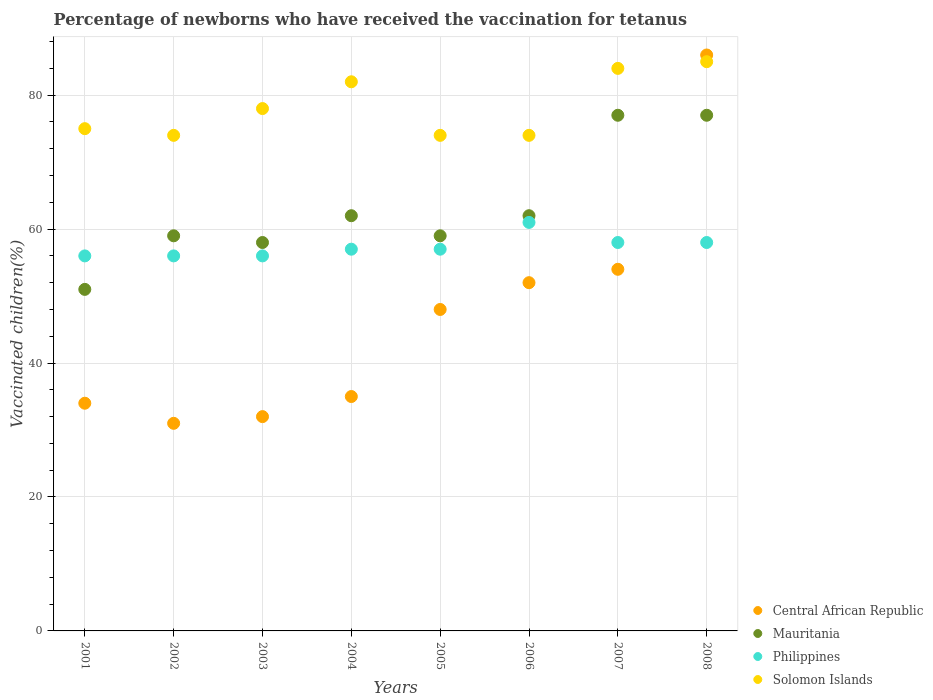How many different coloured dotlines are there?
Offer a very short reply. 4. What is the percentage of vaccinated children in Philippines in 2002?
Make the answer very short. 56. Across all years, what is the maximum percentage of vaccinated children in Central African Republic?
Give a very brief answer. 86. In which year was the percentage of vaccinated children in Philippines maximum?
Give a very brief answer. 2006. What is the total percentage of vaccinated children in Mauritania in the graph?
Provide a succinct answer. 505. What is the difference between the percentage of vaccinated children in Philippines in 2001 and that in 2006?
Your answer should be very brief. -5. What is the difference between the percentage of vaccinated children in Philippines in 2001 and the percentage of vaccinated children in Central African Republic in 2007?
Offer a terse response. 2. What is the average percentage of vaccinated children in Mauritania per year?
Make the answer very short. 63.12. In the year 2008, what is the difference between the percentage of vaccinated children in Central African Republic and percentage of vaccinated children in Mauritania?
Provide a short and direct response. 9. In how many years, is the percentage of vaccinated children in Central African Republic greater than 60 %?
Offer a very short reply. 1. What is the ratio of the percentage of vaccinated children in Solomon Islands in 2004 to that in 2008?
Provide a succinct answer. 0.96. Is the percentage of vaccinated children in Mauritania in 2001 less than that in 2007?
Keep it short and to the point. Yes. Is the difference between the percentage of vaccinated children in Central African Republic in 2002 and 2006 greater than the difference between the percentage of vaccinated children in Mauritania in 2002 and 2006?
Keep it short and to the point. No. What is the difference between the highest and the second highest percentage of vaccinated children in Philippines?
Ensure brevity in your answer.  3. What is the difference between the highest and the lowest percentage of vaccinated children in Solomon Islands?
Ensure brevity in your answer.  11. Is the sum of the percentage of vaccinated children in Central African Republic in 2003 and 2004 greater than the maximum percentage of vaccinated children in Solomon Islands across all years?
Keep it short and to the point. No. Is the percentage of vaccinated children in Philippines strictly less than the percentage of vaccinated children in Mauritania over the years?
Your answer should be very brief. No. How many years are there in the graph?
Offer a very short reply. 8. What is the difference between two consecutive major ticks on the Y-axis?
Offer a very short reply. 20. Does the graph contain any zero values?
Offer a very short reply. No. Where does the legend appear in the graph?
Your response must be concise. Bottom right. How are the legend labels stacked?
Offer a terse response. Vertical. What is the title of the graph?
Your answer should be compact. Percentage of newborns who have received the vaccination for tetanus. Does "Bermuda" appear as one of the legend labels in the graph?
Provide a succinct answer. No. What is the label or title of the Y-axis?
Ensure brevity in your answer.  Vaccinated children(%). What is the Vaccinated children(%) in Philippines in 2001?
Keep it short and to the point. 56. What is the Vaccinated children(%) in Philippines in 2002?
Give a very brief answer. 56. What is the Vaccinated children(%) of Solomon Islands in 2002?
Ensure brevity in your answer.  74. What is the Vaccinated children(%) in Central African Republic in 2003?
Make the answer very short. 32. What is the Vaccinated children(%) in Mauritania in 2003?
Your response must be concise. 58. What is the Vaccinated children(%) in Philippines in 2004?
Provide a succinct answer. 57. What is the Vaccinated children(%) in Solomon Islands in 2004?
Provide a succinct answer. 82. What is the Vaccinated children(%) in Solomon Islands in 2005?
Ensure brevity in your answer.  74. What is the Vaccinated children(%) in Central African Republic in 2006?
Keep it short and to the point. 52. What is the Vaccinated children(%) in Central African Republic in 2007?
Make the answer very short. 54. What is the Vaccinated children(%) in Solomon Islands in 2007?
Provide a succinct answer. 84. What is the Vaccinated children(%) in Central African Republic in 2008?
Your response must be concise. 86. What is the Vaccinated children(%) in Solomon Islands in 2008?
Provide a succinct answer. 85. Across all years, what is the maximum Vaccinated children(%) in Philippines?
Make the answer very short. 61. Across all years, what is the maximum Vaccinated children(%) of Solomon Islands?
Provide a short and direct response. 85. Across all years, what is the minimum Vaccinated children(%) of Central African Republic?
Keep it short and to the point. 31. Across all years, what is the minimum Vaccinated children(%) in Solomon Islands?
Your response must be concise. 74. What is the total Vaccinated children(%) of Central African Republic in the graph?
Ensure brevity in your answer.  372. What is the total Vaccinated children(%) of Mauritania in the graph?
Keep it short and to the point. 505. What is the total Vaccinated children(%) in Philippines in the graph?
Provide a succinct answer. 459. What is the total Vaccinated children(%) of Solomon Islands in the graph?
Give a very brief answer. 626. What is the difference between the Vaccinated children(%) of Solomon Islands in 2001 and that in 2002?
Your response must be concise. 1. What is the difference between the Vaccinated children(%) in Central African Republic in 2001 and that in 2004?
Make the answer very short. -1. What is the difference between the Vaccinated children(%) in Mauritania in 2001 and that in 2004?
Keep it short and to the point. -11. What is the difference between the Vaccinated children(%) of Philippines in 2001 and that in 2004?
Make the answer very short. -1. What is the difference between the Vaccinated children(%) of Solomon Islands in 2001 and that in 2004?
Your answer should be very brief. -7. What is the difference between the Vaccinated children(%) in Central African Republic in 2001 and that in 2005?
Your answer should be very brief. -14. What is the difference between the Vaccinated children(%) in Mauritania in 2001 and that in 2005?
Offer a very short reply. -8. What is the difference between the Vaccinated children(%) of Philippines in 2001 and that in 2005?
Offer a very short reply. -1. What is the difference between the Vaccinated children(%) of Solomon Islands in 2001 and that in 2005?
Provide a short and direct response. 1. What is the difference between the Vaccinated children(%) of Central African Republic in 2001 and that in 2006?
Make the answer very short. -18. What is the difference between the Vaccinated children(%) in Philippines in 2001 and that in 2006?
Give a very brief answer. -5. What is the difference between the Vaccinated children(%) in Solomon Islands in 2001 and that in 2006?
Give a very brief answer. 1. What is the difference between the Vaccinated children(%) of Central African Republic in 2001 and that in 2007?
Your response must be concise. -20. What is the difference between the Vaccinated children(%) of Mauritania in 2001 and that in 2007?
Give a very brief answer. -26. What is the difference between the Vaccinated children(%) in Philippines in 2001 and that in 2007?
Your answer should be very brief. -2. What is the difference between the Vaccinated children(%) of Solomon Islands in 2001 and that in 2007?
Your answer should be very brief. -9. What is the difference between the Vaccinated children(%) in Central African Republic in 2001 and that in 2008?
Your answer should be compact. -52. What is the difference between the Vaccinated children(%) in Mauritania in 2002 and that in 2003?
Your answer should be very brief. 1. What is the difference between the Vaccinated children(%) of Central African Republic in 2002 and that in 2004?
Give a very brief answer. -4. What is the difference between the Vaccinated children(%) of Philippines in 2002 and that in 2004?
Give a very brief answer. -1. What is the difference between the Vaccinated children(%) of Solomon Islands in 2002 and that in 2004?
Offer a very short reply. -8. What is the difference between the Vaccinated children(%) of Central African Republic in 2002 and that in 2005?
Keep it short and to the point. -17. What is the difference between the Vaccinated children(%) in Central African Republic in 2002 and that in 2006?
Your answer should be compact. -21. What is the difference between the Vaccinated children(%) in Mauritania in 2002 and that in 2007?
Offer a terse response. -18. What is the difference between the Vaccinated children(%) of Central African Republic in 2002 and that in 2008?
Your answer should be compact. -55. What is the difference between the Vaccinated children(%) in Philippines in 2002 and that in 2008?
Give a very brief answer. -2. What is the difference between the Vaccinated children(%) of Solomon Islands in 2002 and that in 2008?
Offer a terse response. -11. What is the difference between the Vaccinated children(%) in Philippines in 2003 and that in 2004?
Provide a succinct answer. -1. What is the difference between the Vaccinated children(%) of Central African Republic in 2003 and that in 2005?
Your answer should be very brief. -16. What is the difference between the Vaccinated children(%) of Solomon Islands in 2003 and that in 2005?
Provide a short and direct response. 4. What is the difference between the Vaccinated children(%) of Mauritania in 2003 and that in 2007?
Give a very brief answer. -19. What is the difference between the Vaccinated children(%) of Central African Republic in 2003 and that in 2008?
Offer a terse response. -54. What is the difference between the Vaccinated children(%) of Mauritania in 2003 and that in 2008?
Your answer should be compact. -19. What is the difference between the Vaccinated children(%) in Mauritania in 2004 and that in 2005?
Your response must be concise. 3. What is the difference between the Vaccinated children(%) of Philippines in 2004 and that in 2005?
Offer a terse response. 0. What is the difference between the Vaccinated children(%) of Solomon Islands in 2004 and that in 2005?
Offer a very short reply. 8. What is the difference between the Vaccinated children(%) in Philippines in 2004 and that in 2006?
Make the answer very short. -4. What is the difference between the Vaccinated children(%) of Central African Republic in 2004 and that in 2007?
Give a very brief answer. -19. What is the difference between the Vaccinated children(%) in Mauritania in 2004 and that in 2007?
Provide a succinct answer. -15. What is the difference between the Vaccinated children(%) of Solomon Islands in 2004 and that in 2007?
Offer a very short reply. -2. What is the difference between the Vaccinated children(%) of Central African Republic in 2004 and that in 2008?
Offer a terse response. -51. What is the difference between the Vaccinated children(%) in Philippines in 2004 and that in 2008?
Give a very brief answer. -1. What is the difference between the Vaccinated children(%) of Solomon Islands in 2004 and that in 2008?
Ensure brevity in your answer.  -3. What is the difference between the Vaccinated children(%) in Central African Republic in 2005 and that in 2006?
Give a very brief answer. -4. What is the difference between the Vaccinated children(%) in Philippines in 2005 and that in 2006?
Offer a terse response. -4. What is the difference between the Vaccinated children(%) of Mauritania in 2005 and that in 2007?
Give a very brief answer. -18. What is the difference between the Vaccinated children(%) in Solomon Islands in 2005 and that in 2007?
Your answer should be compact. -10. What is the difference between the Vaccinated children(%) of Central African Republic in 2005 and that in 2008?
Your response must be concise. -38. What is the difference between the Vaccinated children(%) of Mauritania in 2005 and that in 2008?
Your answer should be compact. -18. What is the difference between the Vaccinated children(%) in Solomon Islands in 2006 and that in 2007?
Keep it short and to the point. -10. What is the difference between the Vaccinated children(%) of Central African Republic in 2006 and that in 2008?
Provide a succinct answer. -34. What is the difference between the Vaccinated children(%) in Mauritania in 2006 and that in 2008?
Provide a short and direct response. -15. What is the difference between the Vaccinated children(%) of Philippines in 2006 and that in 2008?
Give a very brief answer. 3. What is the difference between the Vaccinated children(%) in Solomon Islands in 2006 and that in 2008?
Provide a short and direct response. -11. What is the difference between the Vaccinated children(%) of Central African Republic in 2007 and that in 2008?
Offer a very short reply. -32. What is the difference between the Vaccinated children(%) in Mauritania in 2007 and that in 2008?
Provide a succinct answer. 0. What is the difference between the Vaccinated children(%) of Philippines in 2007 and that in 2008?
Offer a terse response. 0. What is the difference between the Vaccinated children(%) of Central African Republic in 2001 and the Vaccinated children(%) of Mauritania in 2002?
Your response must be concise. -25. What is the difference between the Vaccinated children(%) of Central African Republic in 2001 and the Vaccinated children(%) of Solomon Islands in 2002?
Keep it short and to the point. -40. What is the difference between the Vaccinated children(%) in Central African Republic in 2001 and the Vaccinated children(%) in Solomon Islands in 2003?
Your answer should be very brief. -44. What is the difference between the Vaccinated children(%) in Mauritania in 2001 and the Vaccinated children(%) in Solomon Islands in 2003?
Make the answer very short. -27. What is the difference between the Vaccinated children(%) in Philippines in 2001 and the Vaccinated children(%) in Solomon Islands in 2003?
Offer a terse response. -22. What is the difference between the Vaccinated children(%) of Central African Republic in 2001 and the Vaccinated children(%) of Solomon Islands in 2004?
Ensure brevity in your answer.  -48. What is the difference between the Vaccinated children(%) in Mauritania in 2001 and the Vaccinated children(%) in Philippines in 2004?
Ensure brevity in your answer.  -6. What is the difference between the Vaccinated children(%) in Mauritania in 2001 and the Vaccinated children(%) in Solomon Islands in 2004?
Your response must be concise. -31. What is the difference between the Vaccinated children(%) in Central African Republic in 2001 and the Vaccinated children(%) in Philippines in 2005?
Provide a short and direct response. -23. What is the difference between the Vaccinated children(%) in Mauritania in 2001 and the Vaccinated children(%) in Philippines in 2005?
Make the answer very short. -6. What is the difference between the Vaccinated children(%) in Central African Republic in 2001 and the Vaccinated children(%) in Mauritania in 2006?
Provide a succinct answer. -28. What is the difference between the Vaccinated children(%) of Central African Republic in 2001 and the Vaccinated children(%) of Mauritania in 2007?
Your answer should be compact. -43. What is the difference between the Vaccinated children(%) in Central African Republic in 2001 and the Vaccinated children(%) in Philippines in 2007?
Offer a terse response. -24. What is the difference between the Vaccinated children(%) of Central African Republic in 2001 and the Vaccinated children(%) of Solomon Islands in 2007?
Give a very brief answer. -50. What is the difference between the Vaccinated children(%) of Mauritania in 2001 and the Vaccinated children(%) of Solomon Islands in 2007?
Provide a succinct answer. -33. What is the difference between the Vaccinated children(%) of Central African Republic in 2001 and the Vaccinated children(%) of Mauritania in 2008?
Provide a succinct answer. -43. What is the difference between the Vaccinated children(%) in Central African Republic in 2001 and the Vaccinated children(%) in Philippines in 2008?
Provide a short and direct response. -24. What is the difference between the Vaccinated children(%) in Central African Republic in 2001 and the Vaccinated children(%) in Solomon Islands in 2008?
Provide a short and direct response. -51. What is the difference between the Vaccinated children(%) in Mauritania in 2001 and the Vaccinated children(%) in Philippines in 2008?
Provide a short and direct response. -7. What is the difference between the Vaccinated children(%) of Mauritania in 2001 and the Vaccinated children(%) of Solomon Islands in 2008?
Keep it short and to the point. -34. What is the difference between the Vaccinated children(%) of Central African Republic in 2002 and the Vaccinated children(%) of Solomon Islands in 2003?
Your answer should be compact. -47. What is the difference between the Vaccinated children(%) in Mauritania in 2002 and the Vaccinated children(%) in Solomon Islands in 2003?
Your answer should be compact. -19. What is the difference between the Vaccinated children(%) of Philippines in 2002 and the Vaccinated children(%) of Solomon Islands in 2003?
Provide a short and direct response. -22. What is the difference between the Vaccinated children(%) in Central African Republic in 2002 and the Vaccinated children(%) in Mauritania in 2004?
Give a very brief answer. -31. What is the difference between the Vaccinated children(%) in Central African Republic in 2002 and the Vaccinated children(%) in Solomon Islands in 2004?
Provide a succinct answer. -51. What is the difference between the Vaccinated children(%) of Philippines in 2002 and the Vaccinated children(%) of Solomon Islands in 2004?
Keep it short and to the point. -26. What is the difference between the Vaccinated children(%) of Central African Republic in 2002 and the Vaccinated children(%) of Mauritania in 2005?
Give a very brief answer. -28. What is the difference between the Vaccinated children(%) of Central African Republic in 2002 and the Vaccinated children(%) of Philippines in 2005?
Make the answer very short. -26. What is the difference between the Vaccinated children(%) of Central African Republic in 2002 and the Vaccinated children(%) of Solomon Islands in 2005?
Make the answer very short. -43. What is the difference between the Vaccinated children(%) in Philippines in 2002 and the Vaccinated children(%) in Solomon Islands in 2005?
Your answer should be very brief. -18. What is the difference between the Vaccinated children(%) in Central African Republic in 2002 and the Vaccinated children(%) in Mauritania in 2006?
Your answer should be very brief. -31. What is the difference between the Vaccinated children(%) of Central African Republic in 2002 and the Vaccinated children(%) of Solomon Islands in 2006?
Provide a short and direct response. -43. What is the difference between the Vaccinated children(%) of Mauritania in 2002 and the Vaccinated children(%) of Philippines in 2006?
Make the answer very short. -2. What is the difference between the Vaccinated children(%) of Mauritania in 2002 and the Vaccinated children(%) of Solomon Islands in 2006?
Provide a succinct answer. -15. What is the difference between the Vaccinated children(%) in Philippines in 2002 and the Vaccinated children(%) in Solomon Islands in 2006?
Your answer should be compact. -18. What is the difference between the Vaccinated children(%) in Central African Republic in 2002 and the Vaccinated children(%) in Mauritania in 2007?
Keep it short and to the point. -46. What is the difference between the Vaccinated children(%) of Central African Republic in 2002 and the Vaccinated children(%) of Solomon Islands in 2007?
Offer a terse response. -53. What is the difference between the Vaccinated children(%) in Mauritania in 2002 and the Vaccinated children(%) in Philippines in 2007?
Ensure brevity in your answer.  1. What is the difference between the Vaccinated children(%) in Central African Republic in 2002 and the Vaccinated children(%) in Mauritania in 2008?
Ensure brevity in your answer.  -46. What is the difference between the Vaccinated children(%) in Central African Republic in 2002 and the Vaccinated children(%) in Solomon Islands in 2008?
Your answer should be very brief. -54. What is the difference between the Vaccinated children(%) of Central African Republic in 2003 and the Vaccinated children(%) of Philippines in 2004?
Your answer should be very brief. -25. What is the difference between the Vaccinated children(%) in Philippines in 2003 and the Vaccinated children(%) in Solomon Islands in 2004?
Offer a very short reply. -26. What is the difference between the Vaccinated children(%) in Central African Republic in 2003 and the Vaccinated children(%) in Philippines in 2005?
Offer a terse response. -25. What is the difference between the Vaccinated children(%) in Central African Republic in 2003 and the Vaccinated children(%) in Solomon Islands in 2005?
Offer a terse response. -42. What is the difference between the Vaccinated children(%) of Central African Republic in 2003 and the Vaccinated children(%) of Mauritania in 2006?
Your answer should be compact. -30. What is the difference between the Vaccinated children(%) of Central African Republic in 2003 and the Vaccinated children(%) of Philippines in 2006?
Your answer should be very brief. -29. What is the difference between the Vaccinated children(%) of Central African Republic in 2003 and the Vaccinated children(%) of Solomon Islands in 2006?
Ensure brevity in your answer.  -42. What is the difference between the Vaccinated children(%) of Mauritania in 2003 and the Vaccinated children(%) of Philippines in 2006?
Offer a very short reply. -3. What is the difference between the Vaccinated children(%) in Central African Republic in 2003 and the Vaccinated children(%) in Mauritania in 2007?
Provide a succinct answer. -45. What is the difference between the Vaccinated children(%) of Central African Republic in 2003 and the Vaccinated children(%) of Philippines in 2007?
Your response must be concise. -26. What is the difference between the Vaccinated children(%) of Central African Republic in 2003 and the Vaccinated children(%) of Solomon Islands in 2007?
Your answer should be compact. -52. What is the difference between the Vaccinated children(%) in Mauritania in 2003 and the Vaccinated children(%) in Philippines in 2007?
Your response must be concise. 0. What is the difference between the Vaccinated children(%) in Central African Republic in 2003 and the Vaccinated children(%) in Mauritania in 2008?
Offer a terse response. -45. What is the difference between the Vaccinated children(%) of Central African Republic in 2003 and the Vaccinated children(%) of Solomon Islands in 2008?
Your response must be concise. -53. What is the difference between the Vaccinated children(%) of Mauritania in 2003 and the Vaccinated children(%) of Philippines in 2008?
Provide a succinct answer. 0. What is the difference between the Vaccinated children(%) in Mauritania in 2003 and the Vaccinated children(%) in Solomon Islands in 2008?
Make the answer very short. -27. What is the difference between the Vaccinated children(%) in Philippines in 2003 and the Vaccinated children(%) in Solomon Islands in 2008?
Provide a short and direct response. -29. What is the difference between the Vaccinated children(%) of Central African Republic in 2004 and the Vaccinated children(%) of Philippines in 2005?
Your answer should be compact. -22. What is the difference between the Vaccinated children(%) of Central African Republic in 2004 and the Vaccinated children(%) of Solomon Islands in 2005?
Your answer should be compact. -39. What is the difference between the Vaccinated children(%) in Mauritania in 2004 and the Vaccinated children(%) in Solomon Islands in 2005?
Provide a succinct answer. -12. What is the difference between the Vaccinated children(%) in Central African Republic in 2004 and the Vaccinated children(%) in Philippines in 2006?
Your answer should be compact. -26. What is the difference between the Vaccinated children(%) of Central African Republic in 2004 and the Vaccinated children(%) of Solomon Islands in 2006?
Offer a terse response. -39. What is the difference between the Vaccinated children(%) in Mauritania in 2004 and the Vaccinated children(%) in Solomon Islands in 2006?
Provide a short and direct response. -12. What is the difference between the Vaccinated children(%) in Central African Republic in 2004 and the Vaccinated children(%) in Mauritania in 2007?
Make the answer very short. -42. What is the difference between the Vaccinated children(%) of Central African Republic in 2004 and the Vaccinated children(%) of Solomon Islands in 2007?
Ensure brevity in your answer.  -49. What is the difference between the Vaccinated children(%) in Mauritania in 2004 and the Vaccinated children(%) in Philippines in 2007?
Ensure brevity in your answer.  4. What is the difference between the Vaccinated children(%) in Mauritania in 2004 and the Vaccinated children(%) in Solomon Islands in 2007?
Make the answer very short. -22. What is the difference between the Vaccinated children(%) in Philippines in 2004 and the Vaccinated children(%) in Solomon Islands in 2007?
Your response must be concise. -27. What is the difference between the Vaccinated children(%) of Central African Republic in 2004 and the Vaccinated children(%) of Mauritania in 2008?
Offer a very short reply. -42. What is the difference between the Vaccinated children(%) of Central African Republic in 2004 and the Vaccinated children(%) of Solomon Islands in 2008?
Your answer should be very brief. -50. What is the difference between the Vaccinated children(%) of Philippines in 2004 and the Vaccinated children(%) of Solomon Islands in 2008?
Keep it short and to the point. -28. What is the difference between the Vaccinated children(%) of Central African Republic in 2005 and the Vaccinated children(%) of Mauritania in 2006?
Make the answer very short. -14. What is the difference between the Vaccinated children(%) of Central African Republic in 2005 and the Vaccinated children(%) of Philippines in 2006?
Give a very brief answer. -13. What is the difference between the Vaccinated children(%) in Central African Republic in 2005 and the Vaccinated children(%) in Solomon Islands in 2006?
Your response must be concise. -26. What is the difference between the Vaccinated children(%) of Mauritania in 2005 and the Vaccinated children(%) of Philippines in 2006?
Make the answer very short. -2. What is the difference between the Vaccinated children(%) in Mauritania in 2005 and the Vaccinated children(%) in Solomon Islands in 2006?
Offer a very short reply. -15. What is the difference between the Vaccinated children(%) in Central African Republic in 2005 and the Vaccinated children(%) in Mauritania in 2007?
Give a very brief answer. -29. What is the difference between the Vaccinated children(%) in Central African Republic in 2005 and the Vaccinated children(%) in Solomon Islands in 2007?
Give a very brief answer. -36. What is the difference between the Vaccinated children(%) in Mauritania in 2005 and the Vaccinated children(%) in Philippines in 2007?
Provide a succinct answer. 1. What is the difference between the Vaccinated children(%) in Mauritania in 2005 and the Vaccinated children(%) in Solomon Islands in 2007?
Your answer should be very brief. -25. What is the difference between the Vaccinated children(%) in Central African Republic in 2005 and the Vaccinated children(%) in Mauritania in 2008?
Your answer should be very brief. -29. What is the difference between the Vaccinated children(%) in Central African Republic in 2005 and the Vaccinated children(%) in Philippines in 2008?
Your answer should be very brief. -10. What is the difference between the Vaccinated children(%) of Central African Republic in 2005 and the Vaccinated children(%) of Solomon Islands in 2008?
Provide a succinct answer. -37. What is the difference between the Vaccinated children(%) in Central African Republic in 2006 and the Vaccinated children(%) in Mauritania in 2007?
Offer a very short reply. -25. What is the difference between the Vaccinated children(%) in Central African Republic in 2006 and the Vaccinated children(%) in Philippines in 2007?
Provide a short and direct response. -6. What is the difference between the Vaccinated children(%) of Central African Republic in 2006 and the Vaccinated children(%) of Solomon Islands in 2007?
Make the answer very short. -32. What is the difference between the Vaccinated children(%) of Philippines in 2006 and the Vaccinated children(%) of Solomon Islands in 2007?
Ensure brevity in your answer.  -23. What is the difference between the Vaccinated children(%) in Central African Republic in 2006 and the Vaccinated children(%) in Solomon Islands in 2008?
Keep it short and to the point. -33. What is the difference between the Vaccinated children(%) in Central African Republic in 2007 and the Vaccinated children(%) in Solomon Islands in 2008?
Make the answer very short. -31. What is the difference between the Vaccinated children(%) in Mauritania in 2007 and the Vaccinated children(%) in Philippines in 2008?
Give a very brief answer. 19. What is the average Vaccinated children(%) of Central African Republic per year?
Offer a very short reply. 46.5. What is the average Vaccinated children(%) in Mauritania per year?
Provide a short and direct response. 63.12. What is the average Vaccinated children(%) of Philippines per year?
Your answer should be compact. 57.38. What is the average Vaccinated children(%) of Solomon Islands per year?
Your answer should be compact. 78.25. In the year 2001, what is the difference between the Vaccinated children(%) in Central African Republic and Vaccinated children(%) in Mauritania?
Offer a very short reply. -17. In the year 2001, what is the difference between the Vaccinated children(%) in Central African Republic and Vaccinated children(%) in Philippines?
Provide a short and direct response. -22. In the year 2001, what is the difference between the Vaccinated children(%) of Central African Republic and Vaccinated children(%) of Solomon Islands?
Your answer should be compact. -41. In the year 2001, what is the difference between the Vaccinated children(%) of Mauritania and Vaccinated children(%) of Solomon Islands?
Give a very brief answer. -24. In the year 2002, what is the difference between the Vaccinated children(%) of Central African Republic and Vaccinated children(%) of Solomon Islands?
Offer a very short reply. -43. In the year 2002, what is the difference between the Vaccinated children(%) of Mauritania and Vaccinated children(%) of Solomon Islands?
Your response must be concise. -15. In the year 2002, what is the difference between the Vaccinated children(%) of Philippines and Vaccinated children(%) of Solomon Islands?
Make the answer very short. -18. In the year 2003, what is the difference between the Vaccinated children(%) in Central African Republic and Vaccinated children(%) in Mauritania?
Ensure brevity in your answer.  -26. In the year 2003, what is the difference between the Vaccinated children(%) in Central African Republic and Vaccinated children(%) in Solomon Islands?
Provide a succinct answer. -46. In the year 2003, what is the difference between the Vaccinated children(%) of Philippines and Vaccinated children(%) of Solomon Islands?
Offer a very short reply. -22. In the year 2004, what is the difference between the Vaccinated children(%) in Central African Republic and Vaccinated children(%) in Solomon Islands?
Your answer should be very brief. -47. In the year 2004, what is the difference between the Vaccinated children(%) in Mauritania and Vaccinated children(%) in Philippines?
Your answer should be compact. 5. In the year 2005, what is the difference between the Vaccinated children(%) of Central African Republic and Vaccinated children(%) of Solomon Islands?
Ensure brevity in your answer.  -26. In the year 2006, what is the difference between the Vaccinated children(%) in Central African Republic and Vaccinated children(%) in Philippines?
Offer a terse response. -9. In the year 2006, what is the difference between the Vaccinated children(%) of Mauritania and Vaccinated children(%) of Solomon Islands?
Ensure brevity in your answer.  -12. In the year 2006, what is the difference between the Vaccinated children(%) in Philippines and Vaccinated children(%) in Solomon Islands?
Give a very brief answer. -13. In the year 2007, what is the difference between the Vaccinated children(%) in Central African Republic and Vaccinated children(%) in Mauritania?
Provide a succinct answer. -23. In the year 2007, what is the difference between the Vaccinated children(%) in Mauritania and Vaccinated children(%) in Philippines?
Your answer should be compact. 19. In the year 2007, what is the difference between the Vaccinated children(%) in Philippines and Vaccinated children(%) in Solomon Islands?
Give a very brief answer. -26. In the year 2008, what is the difference between the Vaccinated children(%) of Central African Republic and Vaccinated children(%) of Mauritania?
Your answer should be very brief. 9. In the year 2008, what is the difference between the Vaccinated children(%) of Central African Republic and Vaccinated children(%) of Solomon Islands?
Offer a terse response. 1. In the year 2008, what is the difference between the Vaccinated children(%) of Mauritania and Vaccinated children(%) of Philippines?
Offer a terse response. 19. In the year 2008, what is the difference between the Vaccinated children(%) of Mauritania and Vaccinated children(%) of Solomon Islands?
Your answer should be compact. -8. In the year 2008, what is the difference between the Vaccinated children(%) of Philippines and Vaccinated children(%) of Solomon Islands?
Make the answer very short. -27. What is the ratio of the Vaccinated children(%) in Central African Republic in 2001 to that in 2002?
Offer a terse response. 1.1. What is the ratio of the Vaccinated children(%) in Mauritania in 2001 to that in 2002?
Provide a succinct answer. 0.86. What is the ratio of the Vaccinated children(%) of Philippines in 2001 to that in 2002?
Make the answer very short. 1. What is the ratio of the Vaccinated children(%) of Solomon Islands in 2001 to that in 2002?
Your response must be concise. 1.01. What is the ratio of the Vaccinated children(%) of Mauritania in 2001 to that in 2003?
Your response must be concise. 0.88. What is the ratio of the Vaccinated children(%) of Solomon Islands in 2001 to that in 2003?
Make the answer very short. 0.96. What is the ratio of the Vaccinated children(%) of Central African Republic in 2001 to that in 2004?
Offer a terse response. 0.97. What is the ratio of the Vaccinated children(%) of Mauritania in 2001 to that in 2004?
Provide a short and direct response. 0.82. What is the ratio of the Vaccinated children(%) of Philippines in 2001 to that in 2004?
Keep it short and to the point. 0.98. What is the ratio of the Vaccinated children(%) in Solomon Islands in 2001 to that in 2004?
Offer a very short reply. 0.91. What is the ratio of the Vaccinated children(%) of Central African Republic in 2001 to that in 2005?
Keep it short and to the point. 0.71. What is the ratio of the Vaccinated children(%) in Mauritania in 2001 to that in 2005?
Provide a short and direct response. 0.86. What is the ratio of the Vaccinated children(%) of Philippines in 2001 to that in 2005?
Your answer should be very brief. 0.98. What is the ratio of the Vaccinated children(%) in Solomon Islands in 2001 to that in 2005?
Ensure brevity in your answer.  1.01. What is the ratio of the Vaccinated children(%) of Central African Republic in 2001 to that in 2006?
Your answer should be very brief. 0.65. What is the ratio of the Vaccinated children(%) in Mauritania in 2001 to that in 2006?
Provide a short and direct response. 0.82. What is the ratio of the Vaccinated children(%) of Philippines in 2001 to that in 2006?
Your answer should be very brief. 0.92. What is the ratio of the Vaccinated children(%) in Solomon Islands in 2001 to that in 2006?
Provide a succinct answer. 1.01. What is the ratio of the Vaccinated children(%) in Central African Republic in 2001 to that in 2007?
Your answer should be very brief. 0.63. What is the ratio of the Vaccinated children(%) in Mauritania in 2001 to that in 2007?
Make the answer very short. 0.66. What is the ratio of the Vaccinated children(%) of Philippines in 2001 to that in 2007?
Give a very brief answer. 0.97. What is the ratio of the Vaccinated children(%) in Solomon Islands in 2001 to that in 2007?
Ensure brevity in your answer.  0.89. What is the ratio of the Vaccinated children(%) of Central African Republic in 2001 to that in 2008?
Your answer should be compact. 0.4. What is the ratio of the Vaccinated children(%) in Mauritania in 2001 to that in 2008?
Offer a very short reply. 0.66. What is the ratio of the Vaccinated children(%) of Philippines in 2001 to that in 2008?
Keep it short and to the point. 0.97. What is the ratio of the Vaccinated children(%) in Solomon Islands in 2001 to that in 2008?
Give a very brief answer. 0.88. What is the ratio of the Vaccinated children(%) of Central African Republic in 2002 to that in 2003?
Keep it short and to the point. 0.97. What is the ratio of the Vaccinated children(%) of Mauritania in 2002 to that in 2003?
Keep it short and to the point. 1.02. What is the ratio of the Vaccinated children(%) of Philippines in 2002 to that in 2003?
Ensure brevity in your answer.  1. What is the ratio of the Vaccinated children(%) of Solomon Islands in 2002 to that in 2003?
Your answer should be very brief. 0.95. What is the ratio of the Vaccinated children(%) of Central African Republic in 2002 to that in 2004?
Offer a terse response. 0.89. What is the ratio of the Vaccinated children(%) of Mauritania in 2002 to that in 2004?
Ensure brevity in your answer.  0.95. What is the ratio of the Vaccinated children(%) of Philippines in 2002 to that in 2004?
Your response must be concise. 0.98. What is the ratio of the Vaccinated children(%) in Solomon Islands in 2002 to that in 2004?
Your response must be concise. 0.9. What is the ratio of the Vaccinated children(%) in Central African Republic in 2002 to that in 2005?
Give a very brief answer. 0.65. What is the ratio of the Vaccinated children(%) of Philippines in 2002 to that in 2005?
Offer a terse response. 0.98. What is the ratio of the Vaccinated children(%) of Solomon Islands in 2002 to that in 2005?
Your response must be concise. 1. What is the ratio of the Vaccinated children(%) of Central African Republic in 2002 to that in 2006?
Provide a short and direct response. 0.6. What is the ratio of the Vaccinated children(%) of Mauritania in 2002 to that in 2006?
Provide a succinct answer. 0.95. What is the ratio of the Vaccinated children(%) of Philippines in 2002 to that in 2006?
Your answer should be compact. 0.92. What is the ratio of the Vaccinated children(%) of Central African Republic in 2002 to that in 2007?
Offer a terse response. 0.57. What is the ratio of the Vaccinated children(%) of Mauritania in 2002 to that in 2007?
Your response must be concise. 0.77. What is the ratio of the Vaccinated children(%) of Philippines in 2002 to that in 2007?
Offer a very short reply. 0.97. What is the ratio of the Vaccinated children(%) of Solomon Islands in 2002 to that in 2007?
Ensure brevity in your answer.  0.88. What is the ratio of the Vaccinated children(%) of Central African Republic in 2002 to that in 2008?
Give a very brief answer. 0.36. What is the ratio of the Vaccinated children(%) of Mauritania in 2002 to that in 2008?
Ensure brevity in your answer.  0.77. What is the ratio of the Vaccinated children(%) of Philippines in 2002 to that in 2008?
Ensure brevity in your answer.  0.97. What is the ratio of the Vaccinated children(%) in Solomon Islands in 2002 to that in 2008?
Provide a short and direct response. 0.87. What is the ratio of the Vaccinated children(%) in Central African Republic in 2003 to that in 2004?
Your answer should be compact. 0.91. What is the ratio of the Vaccinated children(%) in Mauritania in 2003 to that in 2004?
Your response must be concise. 0.94. What is the ratio of the Vaccinated children(%) in Philippines in 2003 to that in 2004?
Make the answer very short. 0.98. What is the ratio of the Vaccinated children(%) in Solomon Islands in 2003 to that in 2004?
Provide a succinct answer. 0.95. What is the ratio of the Vaccinated children(%) of Central African Republic in 2003 to that in 2005?
Your response must be concise. 0.67. What is the ratio of the Vaccinated children(%) in Mauritania in 2003 to that in 2005?
Provide a succinct answer. 0.98. What is the ratio of the Vaccinated children(%) of Philippines in 2003 to that in 2005?
Your response must be concise. 0.98. What is the ratio of the Vaccinated children(%) of Solomon Islands in 2003 to that in 2005?
Your answer should be very brief. 1.05. What is the ratio of the Vaccinated children(%) in Central African Republic in 2003 to that in 2006?
Give a very brief answer. 0.62. What is the ratio of the Vaccinated children(%) in Mauritania in 2003 to that in 2006?
Ensure brevity in your answer.  0.94. What is the ratio of the Vaccinated children(%) of Philippines in 2003 to that in 2006?
Keep it short and to the point. 0.92. What is the ratio of the Vaccinated children(%) of Solomon Islands in 2003 to that in 2006?
Offer a very short reply. 1.05. What is the ratio of the Vaccinated children(%) of Central African Republic in 2003 to that in 2007?
Provide a short and direct response. 0.59. What is the ratio of the Vaccinated children(%) in Mauritania in 2003 to that in 2007?
Provide a succinct answer. 0.75. What is the ratio of the Vaccinated children(%) in Philippines in 2003 to that in 2007?
Give a very brief answer. 0.97. What is the ratio of the Vaccinated children(%) of Solomon Islands in 2003 to that in 2007?
Ensure brevity in your answer.  0.93. What is the ratio of the Vaccinated children(%) in Central African Republic in 2003 to that in 2008?
Your answer should be compact. 0.37. What is the ratio of the Vaccinated children(%) of Mauritania in 2003 to that in 2008?
Your response must be concise. 0.75. What is the ratio of the Vaccinated children(%) of Philippines in 2003 to that in 2008?
Keep it short and to the point. 0.97. What is the ratio of the Vaccinated children(%) in Solomon Islands in 2003 to that in 2008?
Your answer should be very brief. 0.92. What is the ratio of the Vaccinated children(%) of Central African Republic in 2004 to that in 2005?
Your response must be concise. 0.73. What is the ratio of the Vaccinated children(%) of Mauritania in 2004 to that in 2005?
Offer a terse response. 1.05. What is the ratio of the Vaccinated children(%) in Solomon Islands in 2004 to that in 2005?
Your answer should be very brief. 1.11. What is the ratio of the Vaccinated children(%) of Central African Republic in 2004 to that in 2006?
Keep it short and to the point. 0.67. What is the ratio of the Vaccinated children(%) in Philippines in 2004 to that in 2006?
Give a very brief answer. 0.93. What is the ratio of the Vaccinated children(%) of Solomon Islands in 2004 to that in 2006?
Keep it short and to the point. 1.11. What is the ratio of the Vaccinated children(%) in Central African Republic in 2004 to that in 2007?
Your answer should be compact. 0.65. What is the ratio of the Vaccinated children(%) in Mauritania in 2004 to that in 2007?
Provide a succinct answer. 0.81. What is the ratio of the Vaccinated children(%) in Philippines in 2004 to that in 2007?
Make the answer very short. 0.98. What is the ratio of the Vaccinated children(%) of Solomon Islands in 2004 to that in 2007?
Your response must be concise. 0.98. What is the ratio of the Vaccinated children(%) of Central African Republic in 2004 to that in 2008?
Ensure brevity in your answer.  0.41. What is the ratio of the Vaccinated children(%) in Mauritania in 2004 to that in 2008?
Provide a succinct answer. 0.81. What is the ratio of the Vaccinated children(%) of Philippines in 2004 to that in 2008?
Provide a short and direct response. 0.98. What is the ratio of the Vaccinated children(%) of Solomon Islands in 2004 to that in 2008?
Ensure brevity in your answer.  0.96. What is the ratio of the Vaccinated children(%) of Central African Republic in 2005 to that in 2006?
Offer a very short reply. 0.92. What is the ratio of the Vaccinated children(%) in Mauritania in 2005 to that in 2006?
Give a very brief answer. 0.95. What is the ratio of the Vaccinated children(%) in Philippines in 2005 to that in 2006?
Offer a very short reply. 0.93. What is the ratio of the Vaccinated children(%) of Solomon Islands in 2005 to that in 2006?
Give a very brief answer. 1. What is the ratio of the Vaccinated children(%) in Central African Republic in 2005 to that in 2007?
Offer a terse response. 0.89. What is the ratio of the Vaccinated children(%) of Mauritania in 2005 to that in 2007?
Give a very brief answer. 0.77. What is the ratio of the Vaccinated children(%) in Philippines in 2005 to that in 2007?
Your answer should be compact. 0.98. What is the ratio of the Vaccinated children(%) of Solomon Islands in 2005 to that in 2007?
Ensure brevity in your answer.  0.88. What is the ratio of the Vaccinated children(%) of Central African Republic in 2005 to that in 2008?
Provide a succinct answer. 0.56. What is the ratio of the Vaccinated children(%) in Mauritania in 2005 to that in 2008?
Keep it short and to the point. 0.77. What is the ratio of the Vaccinated children(%) in Philippines in 2005 to that in 2008?
Offer a very short reply. 0.98. What is the ratio of the Vaccinated children(%) of Solomon Islands in 2005 to that in 2008?
Give a very brief answer. 0.87. What is the ratio of the Vaccinated children(%) in Mauritania in 2006 to that in 2007?
Offer a terse response. 0.81. What is the ratio of the Vaccinated children(%) of Philippines in 2006 to that in 2007?
Make the answer very short. 1.05. What is the ratio of the Vaccinated children(%) of Solomon Islands in 2006 to that in 2007?
Give a very brief answer. 0.88. What is the ratio of the Vaccinated children(%) in Central African Republic in 2006 to that in 2008?
Your response must be concise. 0.6. What is the ratio of the Vaccinated children(%) of Mauritania in 2006 to that in 2008?
Give a very brief answer. 0.81. What is the ratio of the Vaccinated children(%) in Philippines in 2006 to that in 2008?
Your response must be concise. 1.05. What is the ratio of the Vaccinated children(%) of Solomon Islands in 2006 to that in 2008?
Ensure brevity in your answer.  0.87. What is the ratio of the Vaccinated children(%) of Central African Republic in 2007 to that in 2008?
Provide a succinct answer. 0.63. What is the ratio of the Vaccinated children(%) of Mauritania in 2007 to that in 2008?
Give a very brief answer. 1. What is the ratio of the Vaccinated children(%) in Philippines in 2007 to that in 2008?
Make the answer very short. 1. What is the ratio of the Vaccinated children(%) in Solomon Islands in 2007 to that in 2008?
Give a very brief answer. 0.99. What is the difference between the highest and the second highest Vaccinated children(%) in Central African Republic?
Provide a succinct answer. 32. What is the difference between the highest and the second highest Vaccinated children(%) of Solomon Islands?
Give a very brief answer. 1. 